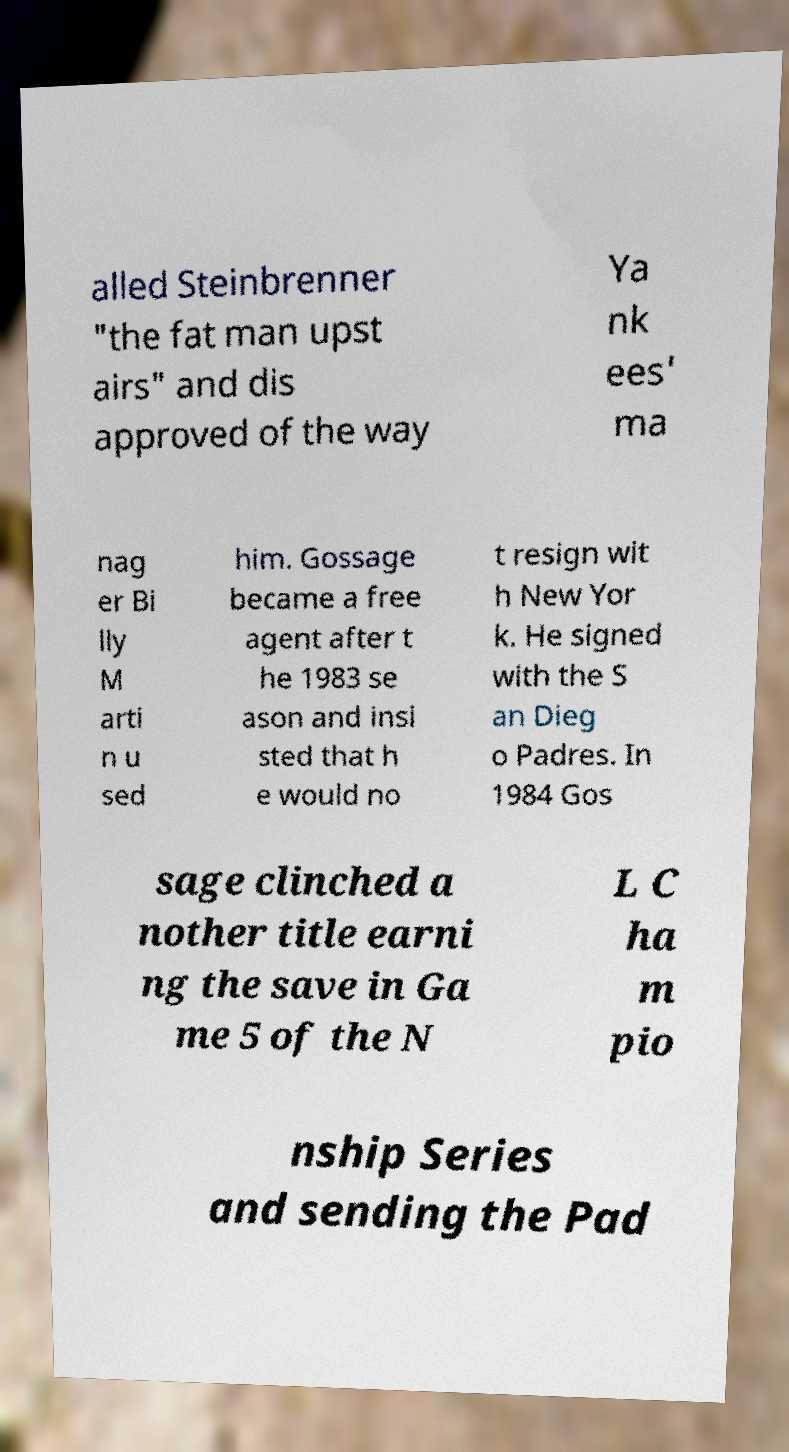Could you assist in decoding the text presented in this image and type it out clearly? alled Steinbrenner "the fat man upst airs" and dis approved of the way Ya nk ees' ma nag er Bi lly M arti n u sed him. Gossage became a free agent after t he 1983 se ason and insi sted that h e would no t resign wit h New Yor k. He signed with the S an Dieg o Padres. In 1984 Gos sage clinched a nother title earni ng the save in Ga me 5 of the N L C ha m pio nship Series and sending the Pad 